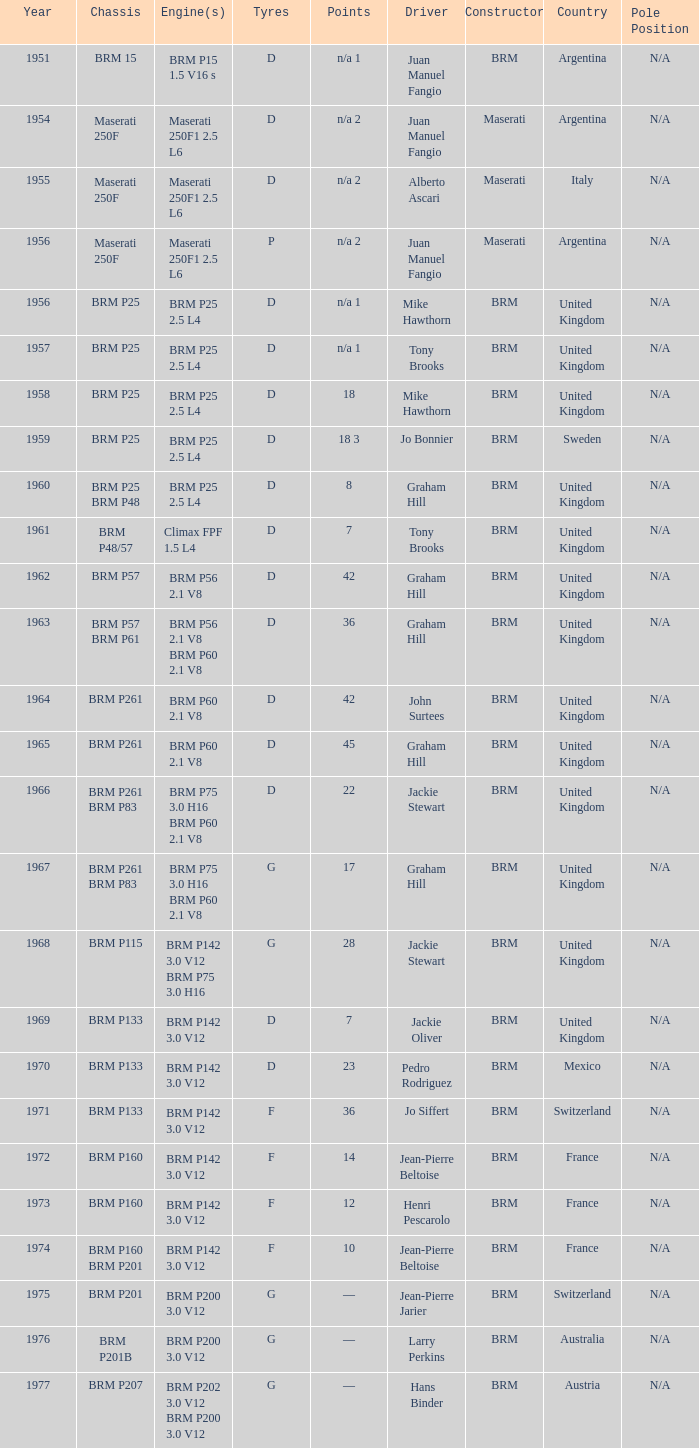Name the chassis for 1970 and tyres of d BRM P133. 